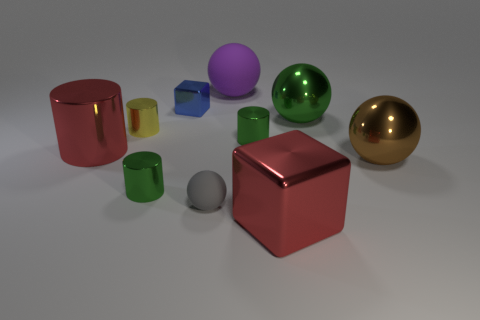How many gray things are either big shiny objects or small metallic cubes?
Provide a short and direct response. 0. What material is the large red thing that is behind the green cylinder in front of the big brown metal thing made of?
Offer a terse response. Metal. Is the shape of the brown metallic thing the same as the small blue thing?
Your answer should be compact. No. What is the color of the ball that is the same size as the yellow shiny thing?
Offer a very short reply. Gray. Are there any large objects that have the same color as the big block?
Make the answer very short. Yes. Are there any red matte cylinders?
Your response must be concise. No. Does the block on the left side of the big red block have the same material as the big green ball?
Your response must be concise. Yes. What is the size of the shiny cube that is the same color as the large metallic cylinder?
Give a very brief answer. Large. How many shiny cylinders are the same size as the gray sphere?
Give a very brief answer. 3. Are there the same number of matte things behind the small yellow cylinder and small yellow metal cubes?
Make the answer very short. No. 